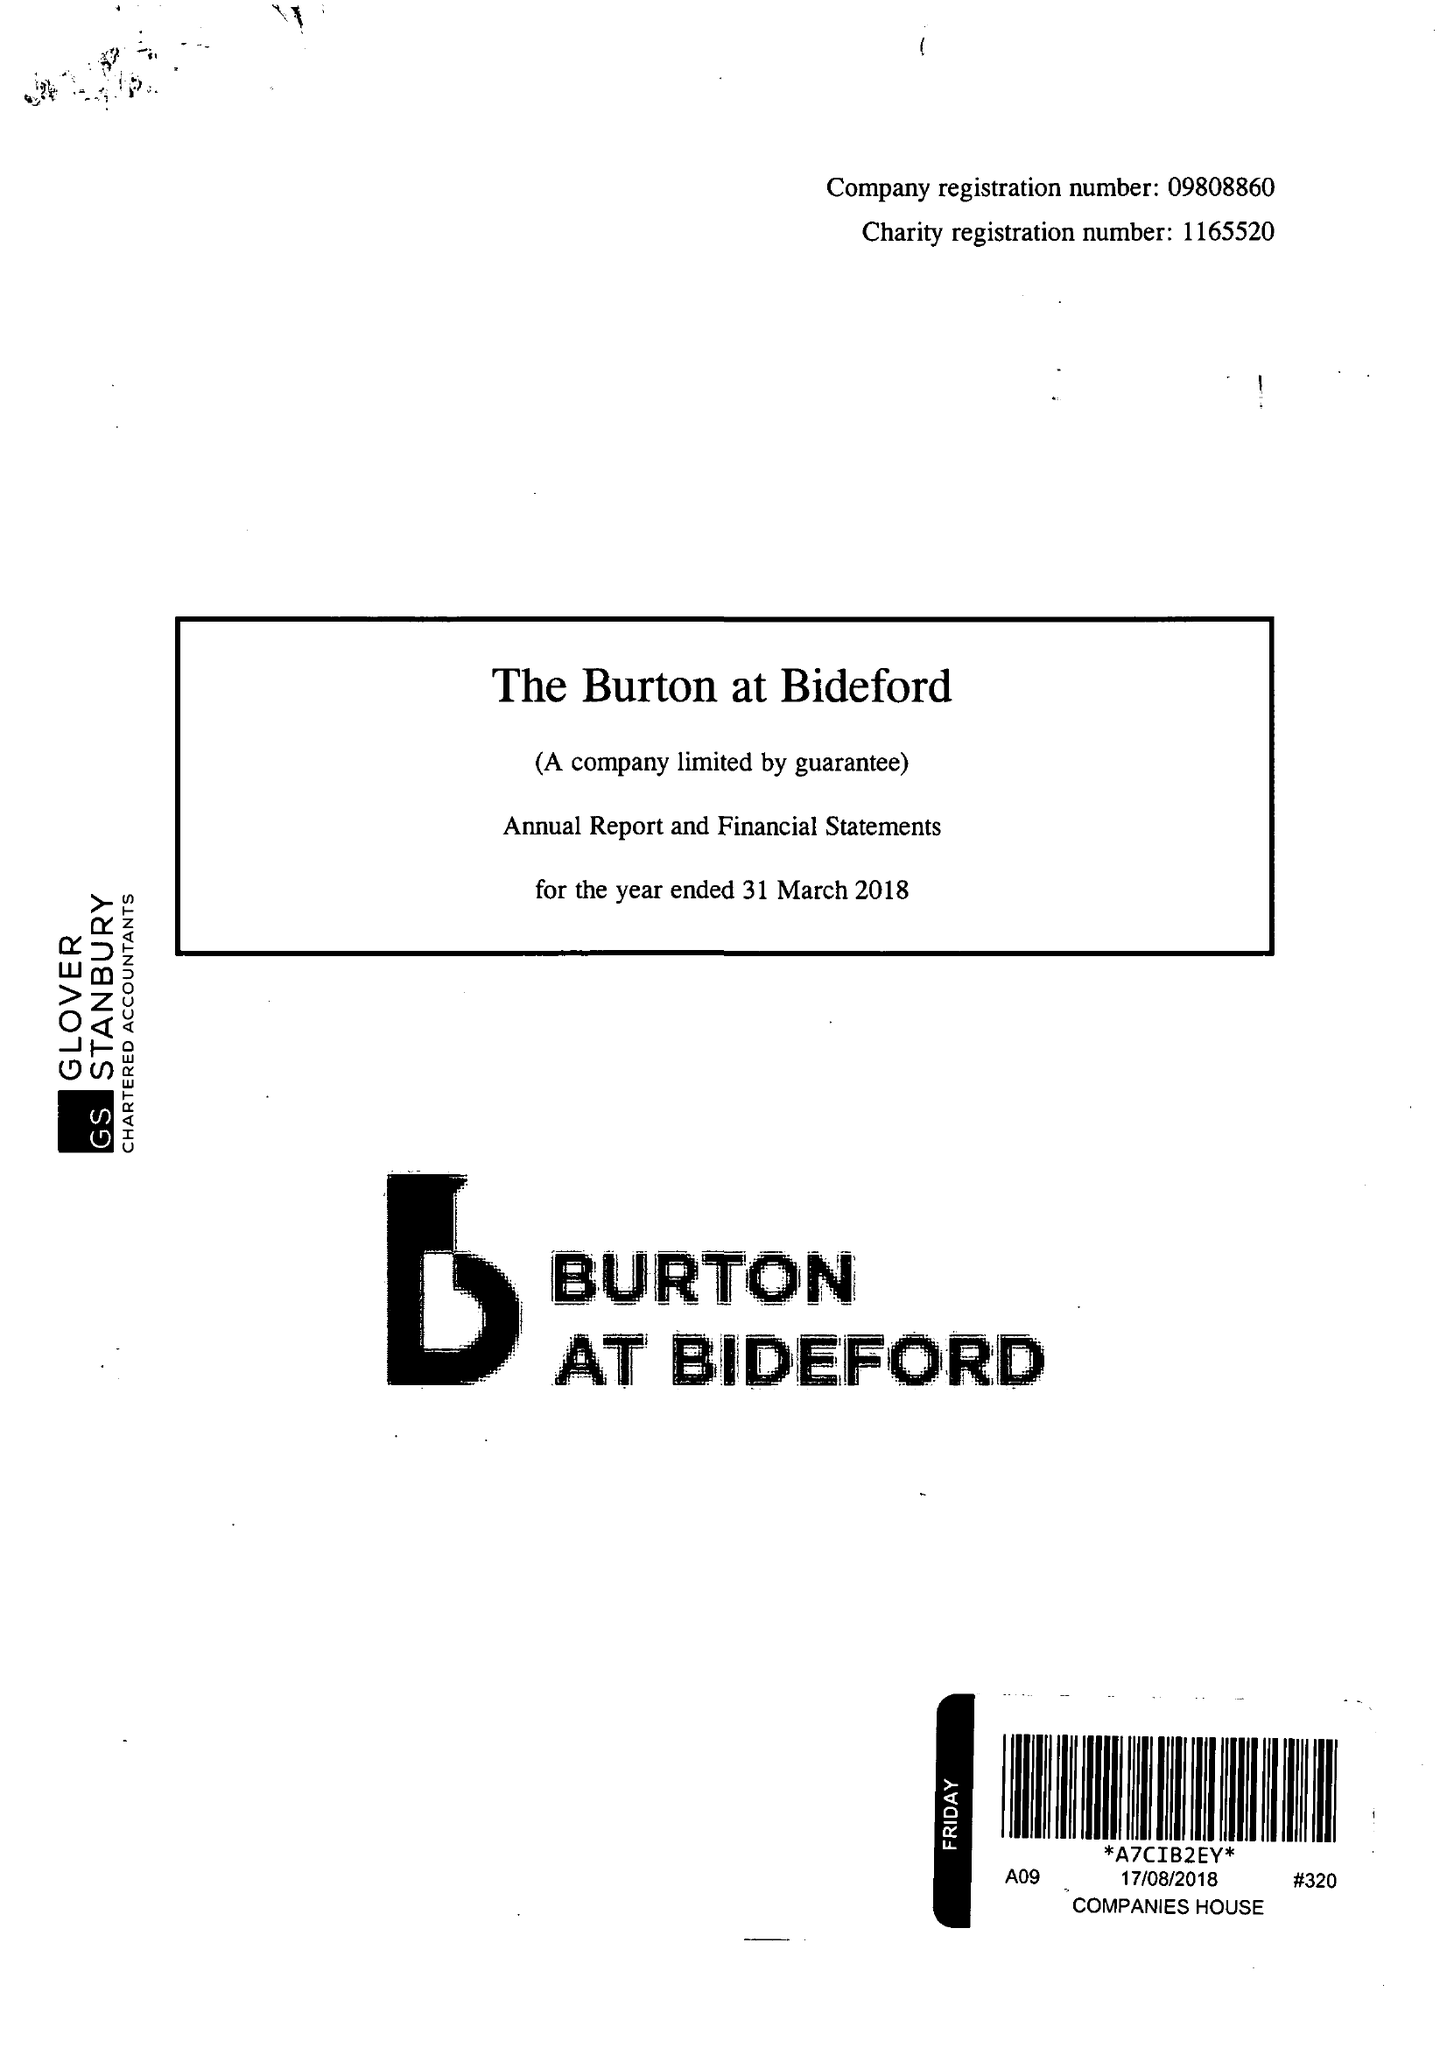What is the value for the spending_annually_in_british_pounds?
Answer the question using a single word or phrase. 273683.00 